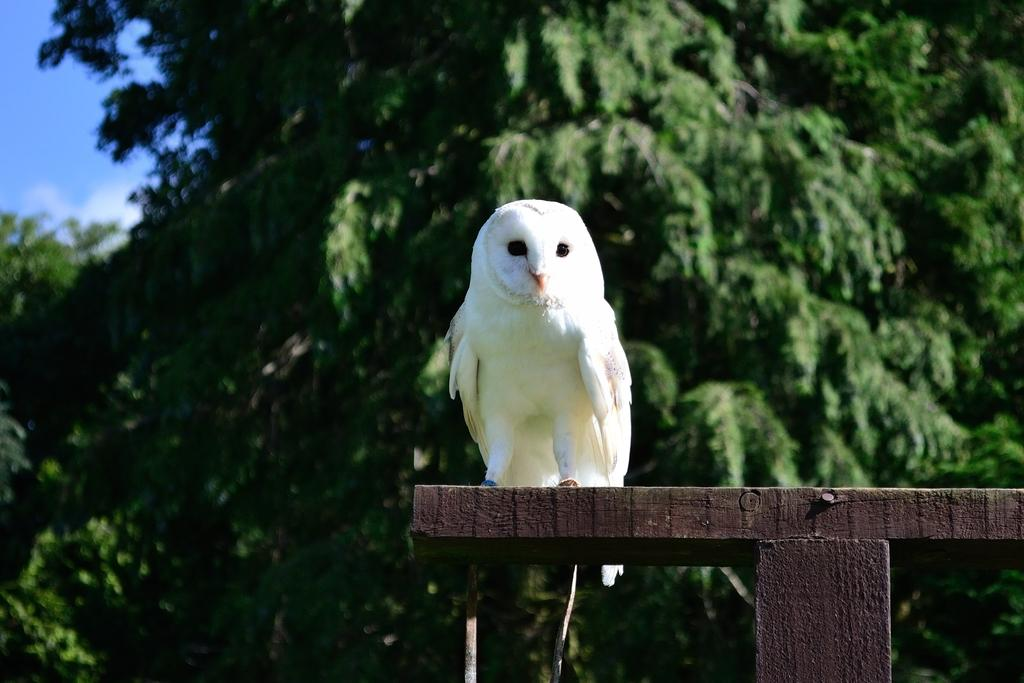What animal is in the middle of the image? There is an owl in the middle of the image. What can be seen in the background of the image? There are trees in the background of the image. What part of the sky is visible in the image? The sky is visible in the top left corner of the image. What type of crack can be seen in the image? There is no crack present in the image. How many sheep are visible in the image? There are no sheep present in the image. 